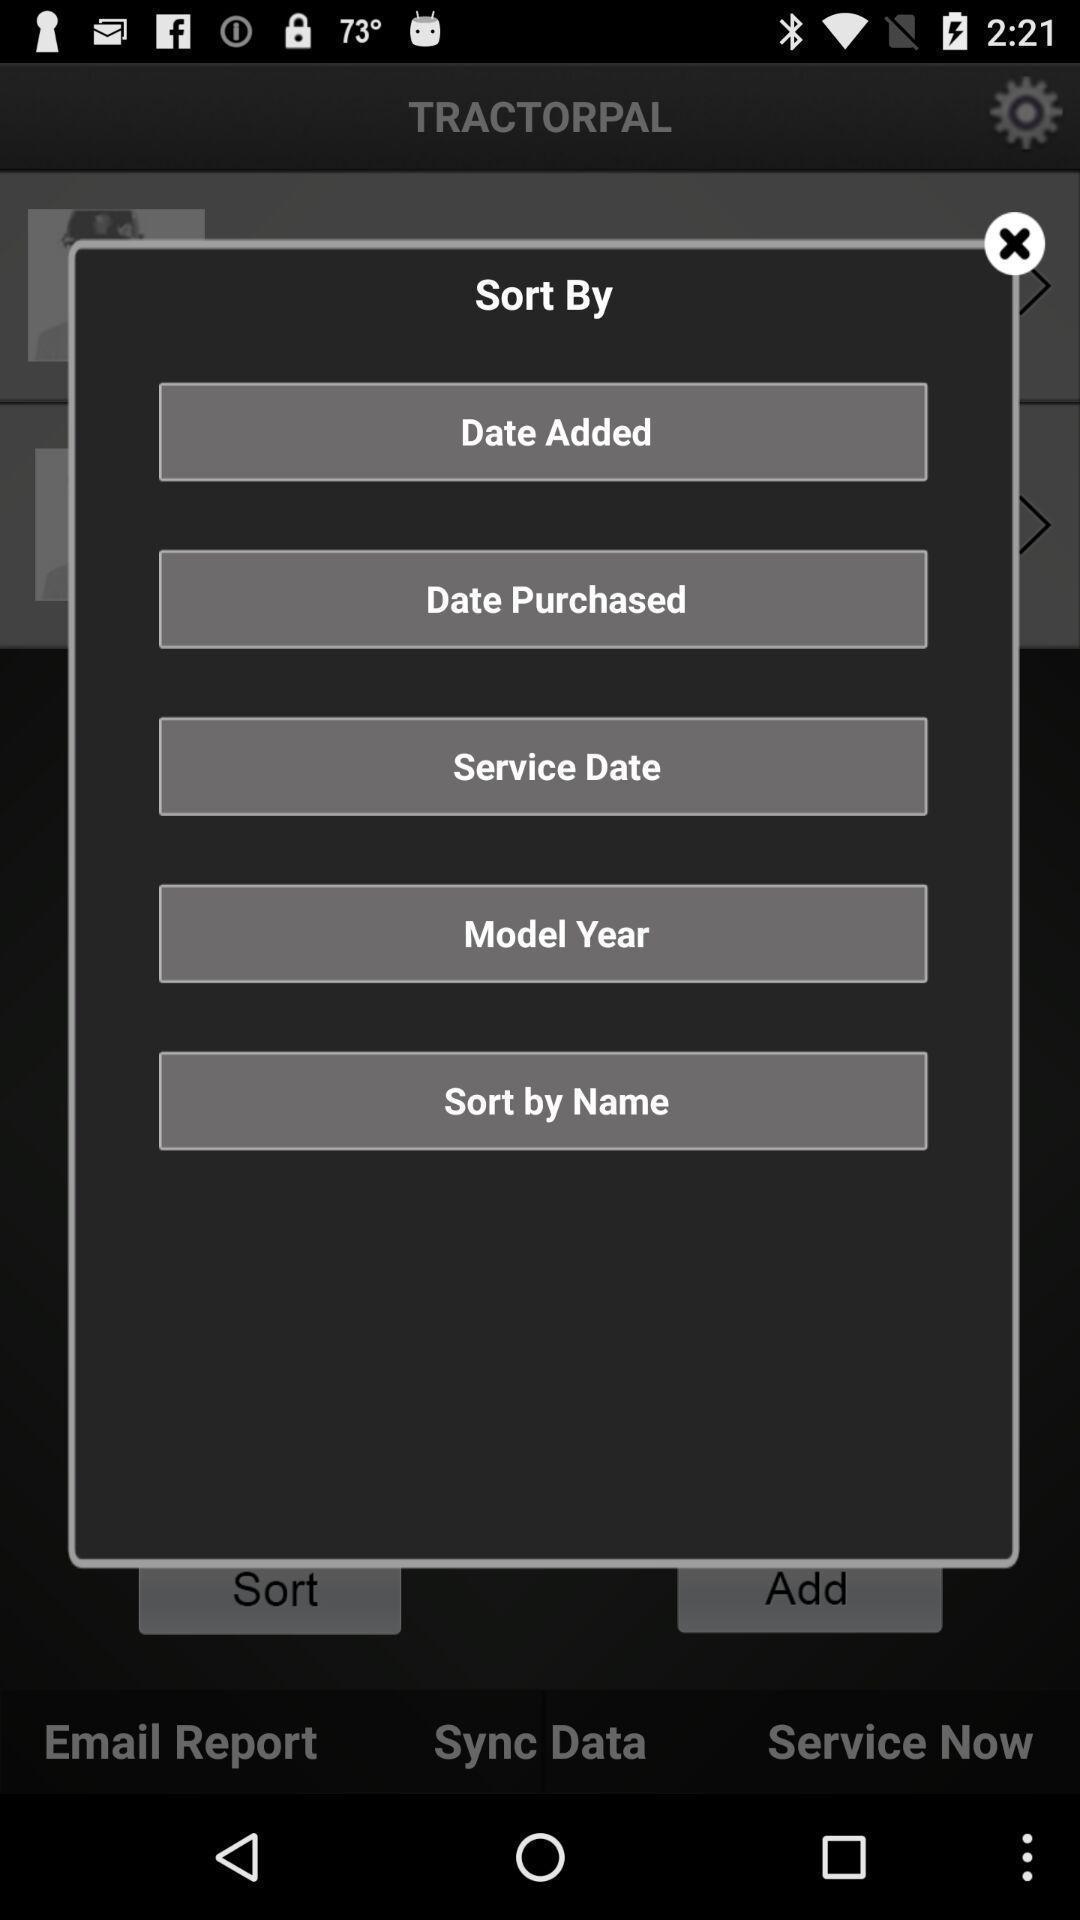What details can you identify in this image? Pop-up showing list of options for sorting. 